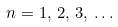<formula> <loc_0><loc_0><loc_500><loc_500>n = 1 , \, 2 , \, 3 , \, \dots</formula> 